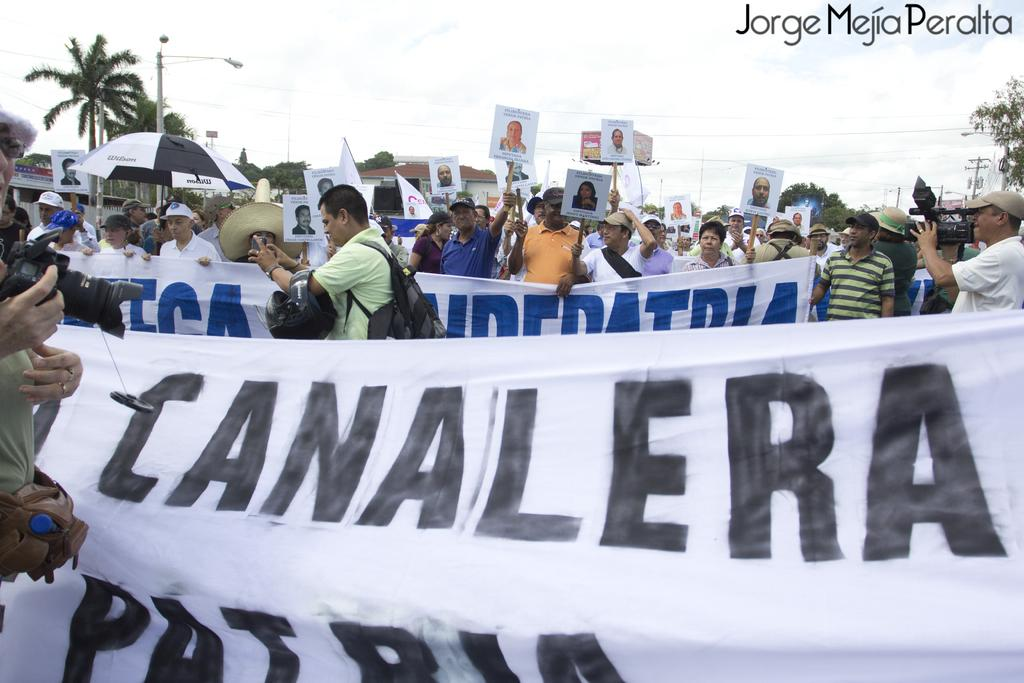What are the people in the image doing? The people in the image are standing and holding banners and posters. What can be seen in the background of the image? There are trees and buildings in the background of the image. What is visible at the top of the image? The sky is visible at the top of the image. Can you tell me how many combs are being used by the people in the image? There is no mention of combs in the image; the people are holding banners and posters. What type of ray is visible in the image? There is no ray present in the image. 